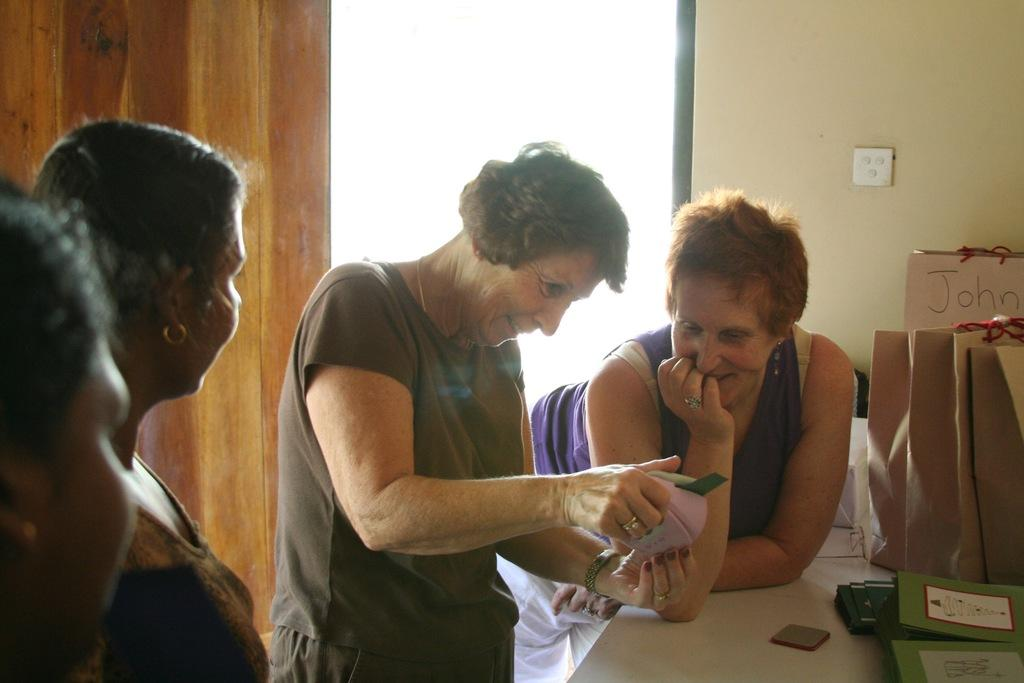What are the persons in the image wearing? The persons in the image are wearing clothes. What can be seen in the image besides the persons? There is a table in the image. Where is the table located in relation to the wall? The table is in front of a wall. What is on the table in the image? There are bags on the table. What type of wall is visible in the top left of the image? There is a wooden wall in the top left of the image. Can you see any hills in the image? There are no hills visible in the image. What color is the chalk used to draw on the wall in the image? There is no chalk or drawing on the wall in the image. 